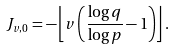Convert formula to latex. <formula><loc_0><loc_0><loc_500><loc_500>J _ { v , 0 } = - \left \lfloor v \left ( \frac { \log q } { \log p } - 1 \right ) \right \rfloor .</formula> 